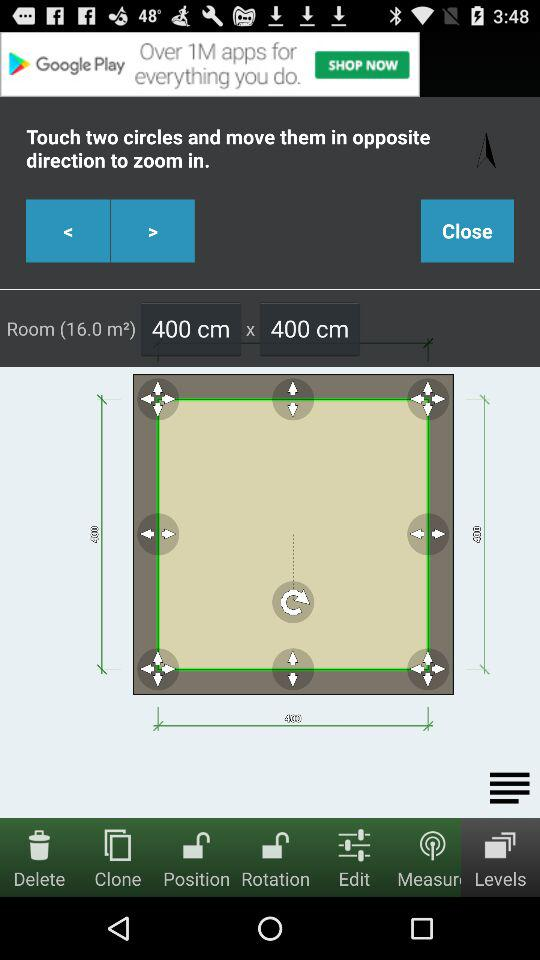What are the dimensions of the room? The dimensions of the room are 400 cm x 400 cm. 